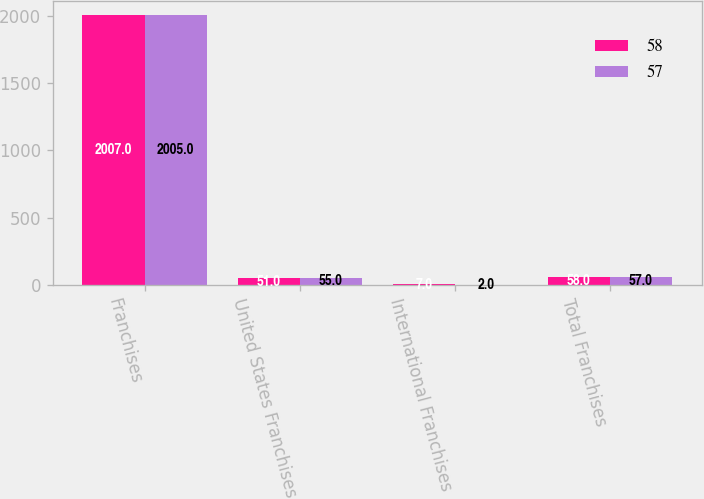Convert chart. <chart><loc_0><loc_0><loc_500><loc_500><stacked_bar_chart><ecel><fcel>Franchises<fcel>United States Franchises<fcel>International Franchises<fcel>Total Franchises<nl><fcel>58<fcel>2007<fcel>51<fcel>7<fcel>58<nl><fcel>57<fcel>2005<fcel>55<fcel>2<fcel>57<nl></chart> 